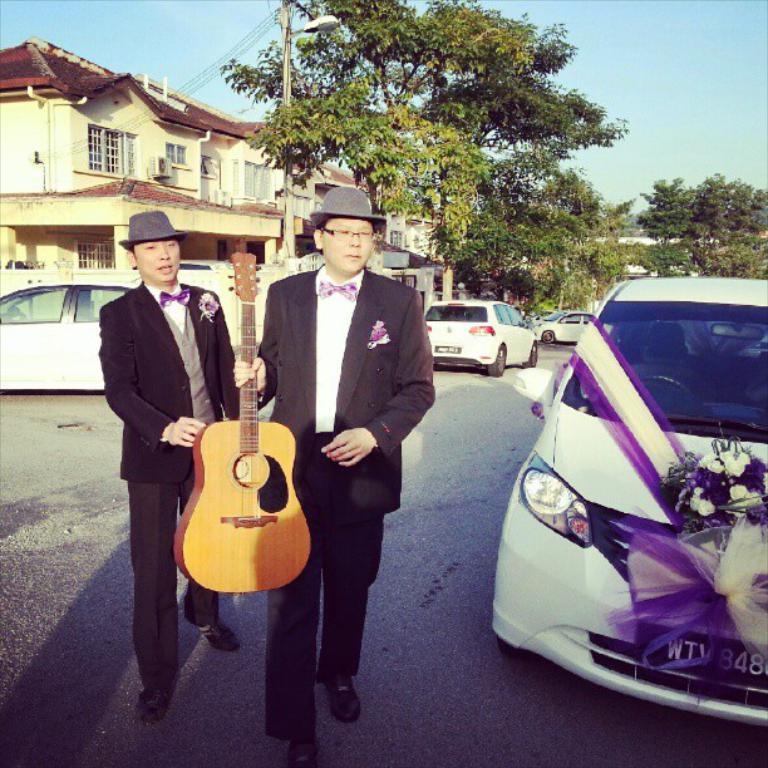What are the two men in the image doing? The two men in the image are walking on the road. What is one of the men holding in his hand? One person is holding a guitar in his hand. What can be seen in the background of the image? There are buildings, trees, an electric pole, vehicles, and the sky visible in the background. Can you tell me how many dogs are walking with the men in the image? There are no dogs present in the image; only the two men and the guitar can be seen. What type of bird is perched on the electric pole in the image? There is no bird, specifically a robin, present on the electric pole in the image. 